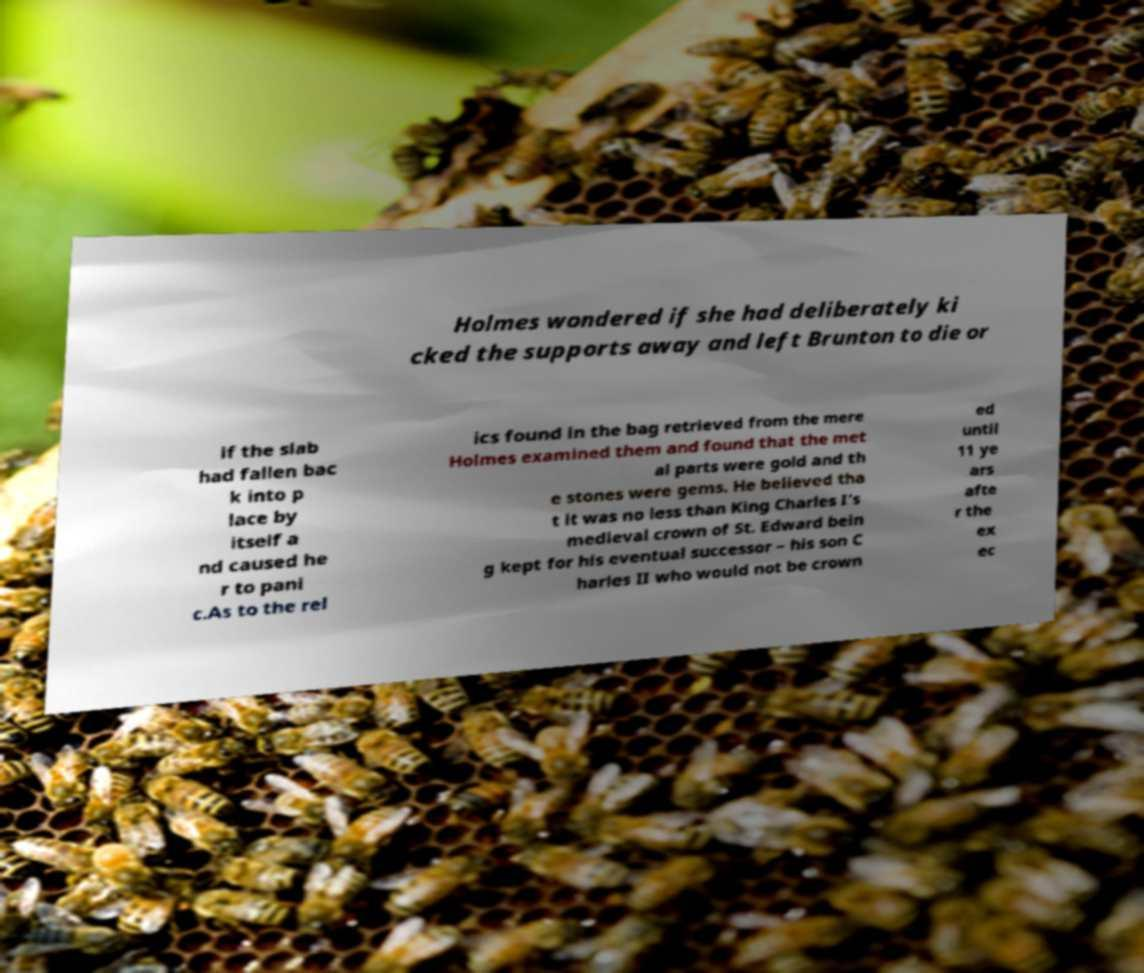Could you assist in decoding the text presented in this image and type it out clearly? Holmes wondered if she had deliberately ki cked the supports away and left Brunton to die or if the slab had fallen bac k into p lace by itself a nd caused he r to pani c.As to the rel ics found in the bag retrieved from the mere Holmes examined them and found that the met al parts were gold and th e stones were gems. He believed tha t it was no less than King Charles I’s medieval crown of St. Edward bein g kept for his eventual successor – his son C harles II who would not be crown ed until 11 ye ars afte r the ex ec 